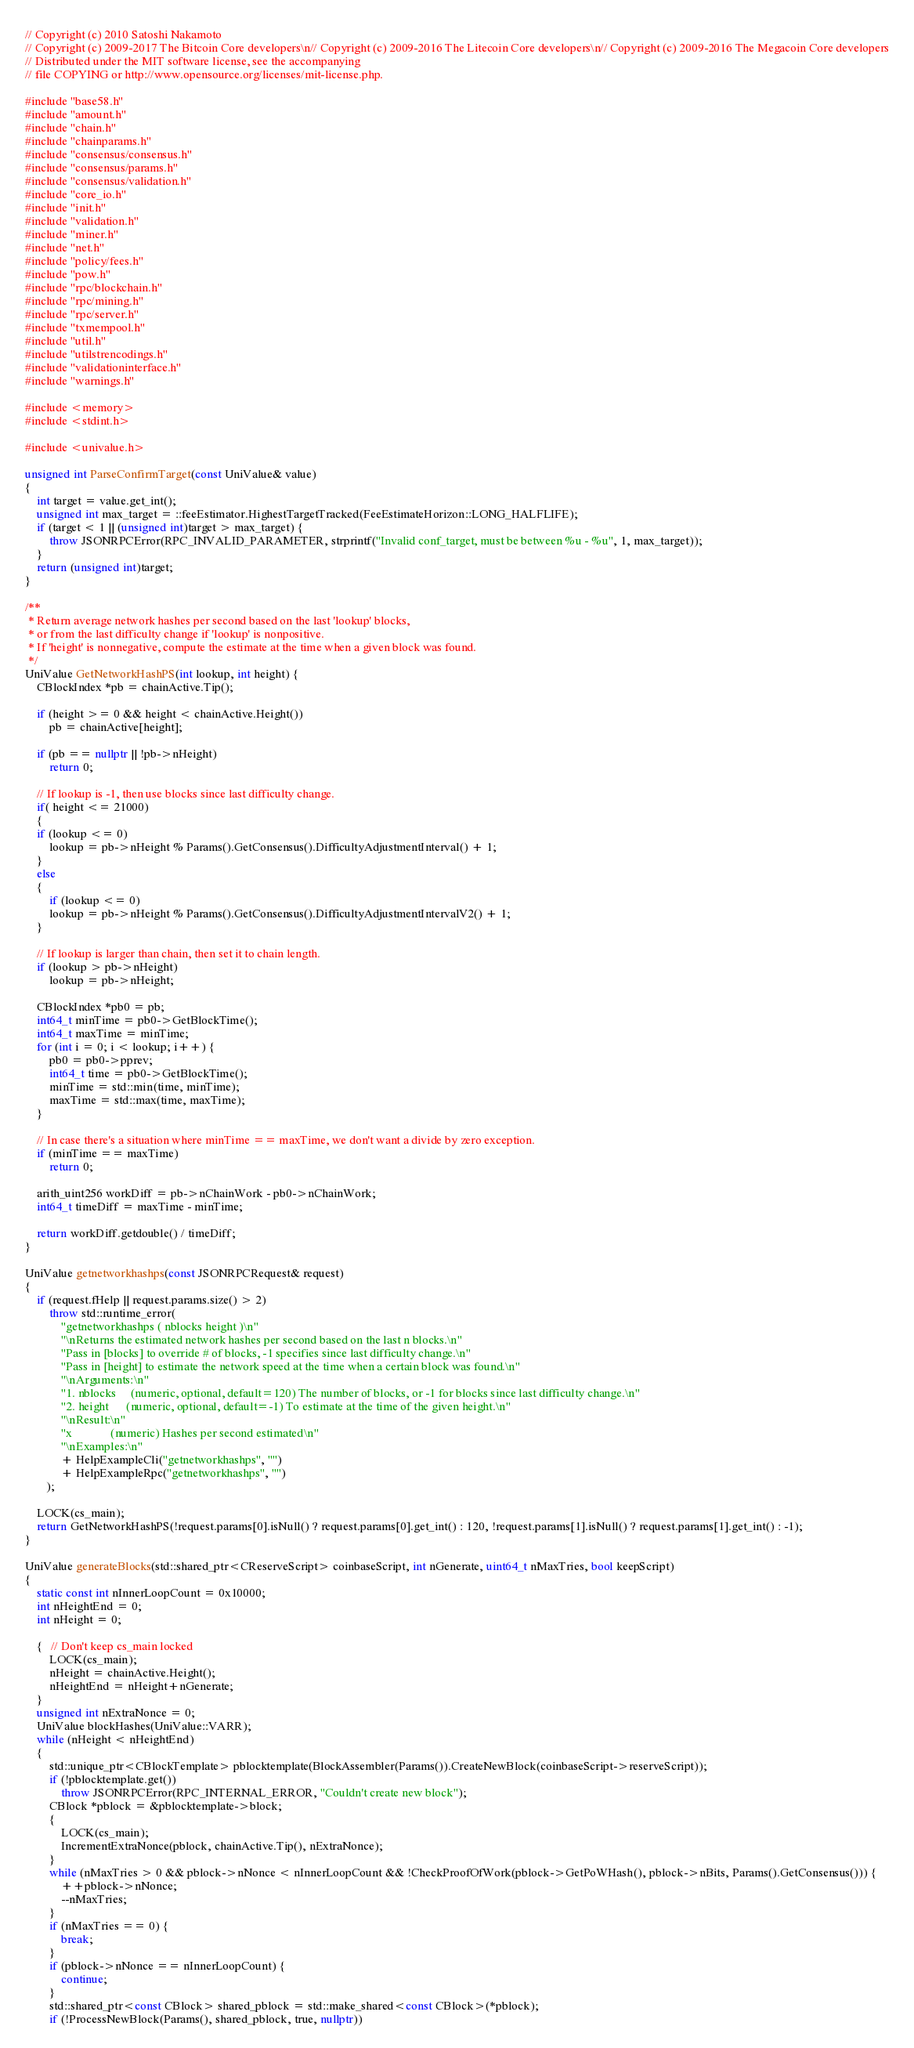<code> <loc_0><loc_0><loc_500><loc_500><_C++_>// Copyright (c) 2010 Satoshi Nakamoto
// Copyright (c) 2009-2017 The Bitcoin Core developers\n// Copyright (c) 2009-2016 The Litecoin Core developers\n// Copyright (c) 2009-2016 The Megacoin Core developers
// Distributed under the MIT software license, see the accompanying
// file COPYING or http://www.opensource.org/licenses/mit-license.php.

#include "base58.h"
#include "amount.h"
#include "chain.h"
#include "chainparams.h"
#include "consensus/consensus.h"
#include "consensus/params.h"
#include "consensus/validation.h"
#include "core_io.h"
#include "init.h"
#include "validation.h"
#include "miner.h"
#include "net.h"
#include "policy/fees.h"
#include "pow.h"
#include "rpc/blockchain.h"
#include "rpc/mining.h"
#include "rpc/server.h"
#include "txmempool.h"
#include "util.h"
#include "utilstrencodings.h"
#include "validationinterface.h"
#include "warnings.h"

#include <memory>
#include <stdint.h>

#include <univalue.h>

unsigned int ParseConfirmTarget(const UniValue& value)
{
    int target = value.get_int();
    unsigned int max_target = ::feeEstimator.HighestTargetTracked(FeeEstimateHorizon::LONG_HALFLIFE);
    if (target < 1 || (unsigned int)target > max_target) {
        throw JSONRPCError(RPC_INVALID_PARAMETER, strprintf("Invalid conf_target, must be between %u - %u", 1, max_target));
    }
    return (unsigned int)target;
}

/**
 * Return average network hashes per second based on the last 'lookup' blocks,
 * or from the last difficulty change if 'lookup' is nonpositive.
 * If 'height' is nonnegative, compute the estimate at the time when a given block was found.
 */
UniValue GetNetworkHashPS(int lookup, int height) {
    CBlockIndex *pb = chainActive.Tip();

    if (height >= 0 && height < chainActive.Height())
        pb = chainActive[height];

    if (pb == nullptr || !pb->nHeight)
        return 0;

    // If lookup is -1, then use blocks since last difficulty change.
    if( height <= 21000)
    {
    if (lookup <= 0)
        lookup = pb->nHeight % Params().GetConsensus().DifficultyAdjustmentInterval() + 1;
    }
    else
    {    
        if (lookup <= 0)
        lookup = pb->nHeight % Params().GetConsensus().DifficultyAdjustmentIntervalV2() + 1;
    }

    // If lookup is larger than chain, then set it to chain length.
    if (lookup > pb->nHeight)
        lookup = pb->nHeight;

    CBlockIndex *pb0 = pb;
    int64_t minTime = pb0->GetBlockTime();
    int64_t maxTime = minTime;
    for (int i = 0; i < lookup; i++) {
        pb0 = pb0->pprev;
        int64_t time = pb0->GetBlockTime();
        minTime = std::min(time, minTime);
        maxTime = std::max(time, maxTime);
    }

    // In case there's a situation where minTime == maxTime, we don't want a divide by zero exception.
    if (minTime == maxTime)
        return 0;

    arith_uint256 workDiff = pb->nChainWork - pb0->nChainWork;
    int64_t timeDiff = maxTime - minTime;

    return workDiff.getdouble() / timeDiff;
}

UniValue getnetworkhashps(const JSONRPCRequest& request)
{
    if (request.fHelp || request.params.size() > 2)
        throw std::runtime_error(
            "getnetworkhashps ( nblocks height )\n"
            "\nReturns the estimated network hashes per second based on the last n blocks.\n"
            "Pass in [blocks] to override # of blocks, -1 specifies since last difficulty change.\n"
            "Pass in [height] to estimate the network speed at the time when a certain block was found.\n"
            "\nArguments:\n"
            "1. nblocks     (numeric, optional, default=120) The number of blocks, or -1 for blocks since last difficulty change.\n"
            "2. height      (numeric, optional, default=-1) To estimate at the time of the given height.\n"
            "\nResult:\n"
            "x             (numeric) Hashes per second estimated\n"
            "\nExamples:\n"
            + HelpExampleCli("getnetworkhashps", "")
            + HelpExampleRpc("getnetworkhashps", "")
       );

    LOCK(cs_main);
    return GetNetworkHashPS(!request.params[0].isNull() ? request.params[0].get_int() : 120, !request.params[1].isNull() ? request.params[1].get_int() : -1);
}

UniValue generateBlocks(std::shared_ptr<CReserveScript> coinbaseScript, int nGenerate, uint64_t nMaxTries, bool keepScript)
{
    static const int nInnerLoopCount = 0x10000;
    int nHeightEnd = 0;
    int nHeight = 0;

    {   // Don't keep cs_main locked
        LOCK(cs_main);
        nHeight = chainActive.Height();
        nHeightEnd = nHeight+nGenerate;
    }
    unsigned int nExtraNonce = 0;
    UniValue blockHashes(UniValue::VARR);
    while (nHeight < nHeightEnd)
    {
        std::unique_ptr<CBlockTemplate> pblocktemplate(BlockAssembler(Params()).CreateNewBlock(coinbaseScript->reserveScript));
        if (!pblocktemplate.get())
            throw JSONRPCError(RPC_INTERNAL_ERROR, "Couldn't create new block");
        CBlock *pblock = &pblocktemplate->block;
        {
            LOCK(cs_main);
            IncrementExtraNonce(pblock, chainActive.Tip(), nExtraNonce);
        }
        while (nMaxTries > 0 && pblock->nNonce < nInnerLoopCount && !CheckProofOfWork(pblock->GetPoWHash(), pblock->nBits, Params().GetConsensus())) {
            ++pblock->nNonce;
            --nMaxTries;
        }
        if (nMaxTries == 0) {
            break;
        }
        if (pblock->nNonce == nInnerLoopCount) {
            continue;
        }
        std::shared_ptr<const CBlock> shared_pblock = std::make_shared<const CBlock>(*pblock);
        if (!ProcessNewBlock(Params(), shared_pblock, true, nullptr))</code> 